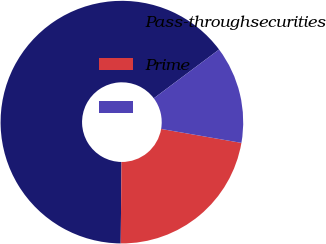Convert chart. <chart><loc_0><loc_0><loc_500><loc_500><pie_chart><fcel>Pass-throughsecurities<fcel>Prime<fcel>Unnamed: 2<nl><fcel>64.63%<fcel>22.42%<fcel>12.95%<nl></chart> 